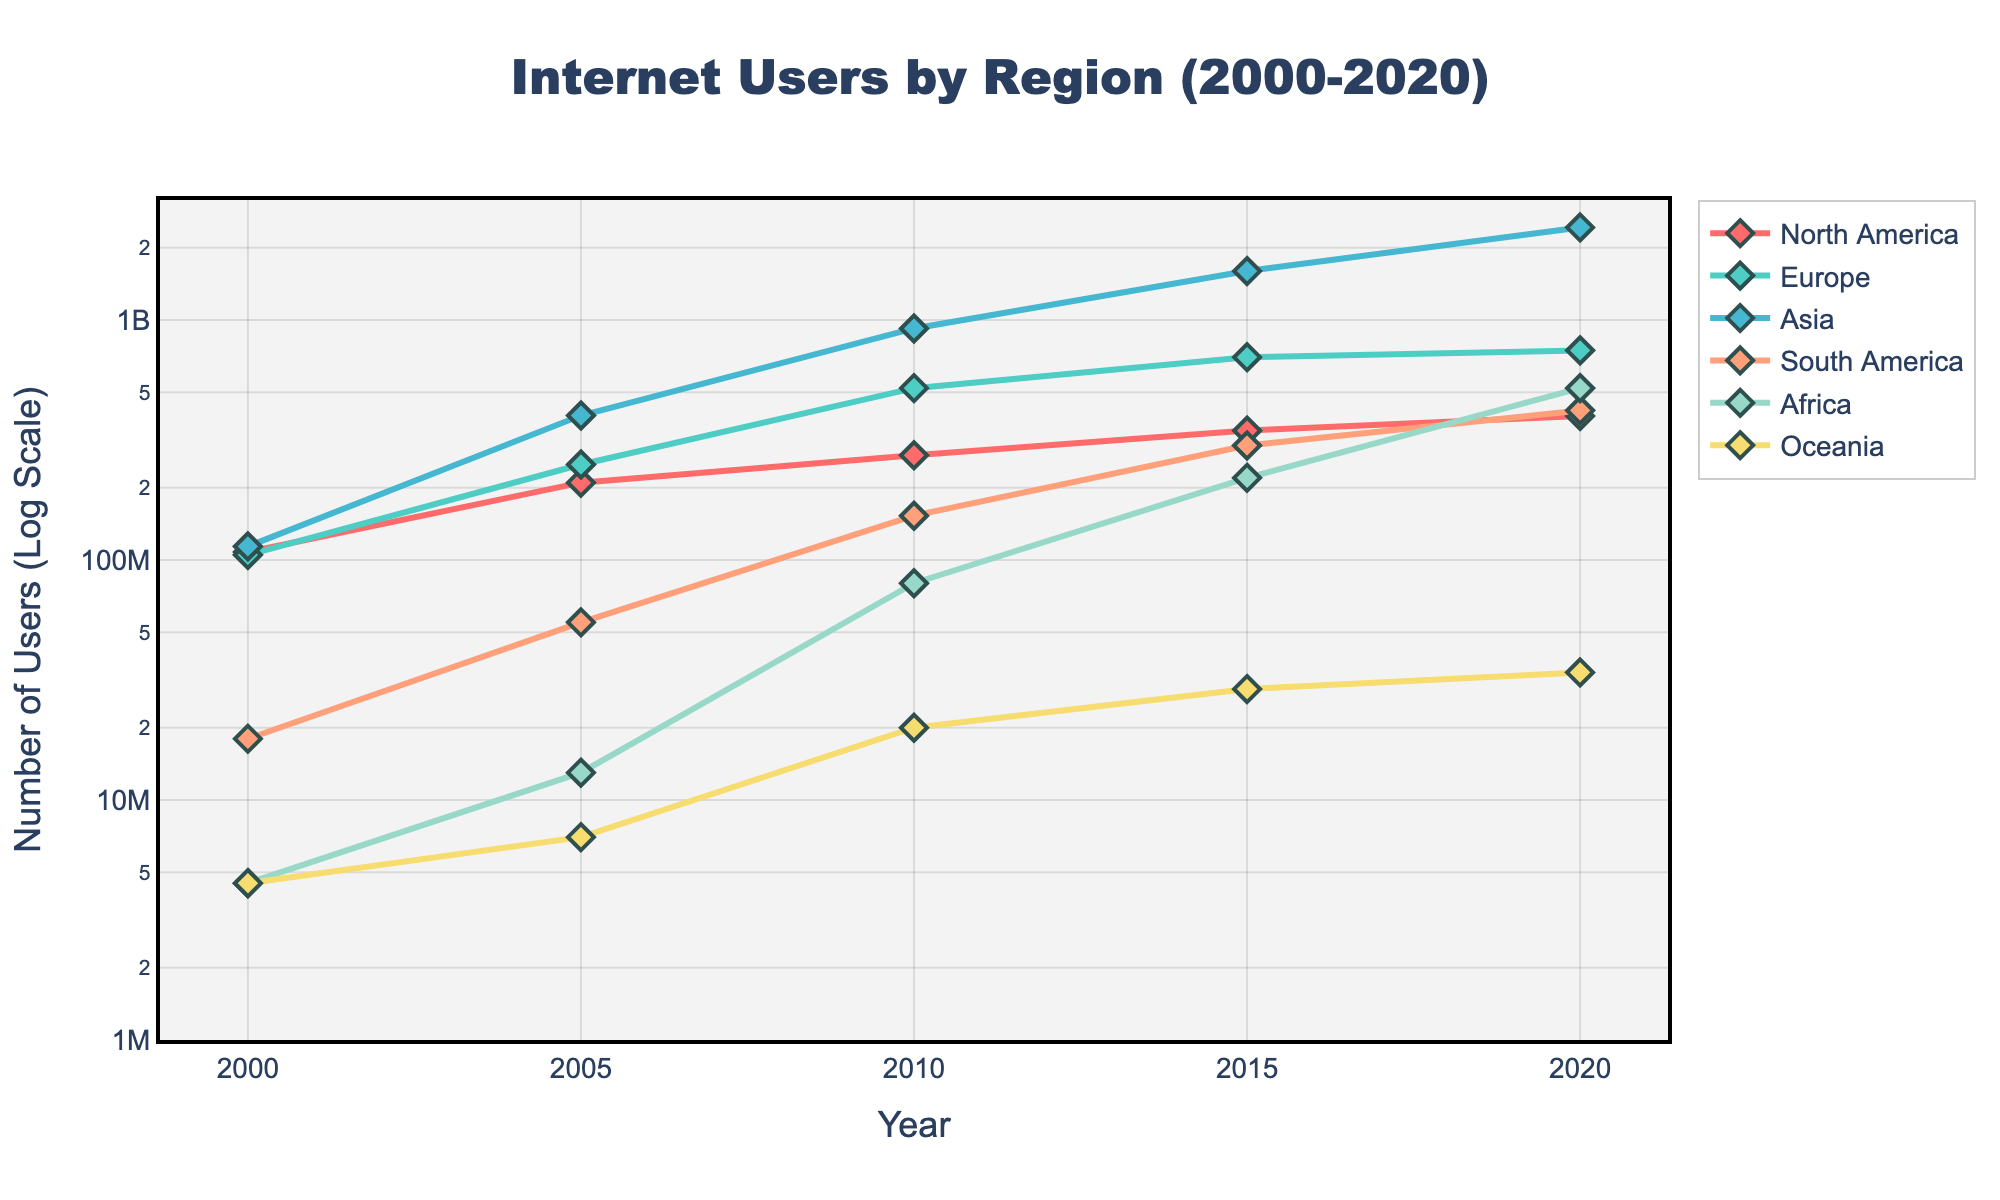What is the title of the plot? The title is usually at the top of the plot and provides a brief description of what the plot represents. Here, it's right in the center top of the plot, above the lines and markers.
Answer: Internet Users by Region (2000-2020) What does the y-axis represent? The y-axis typically represents a quantitative measure. In this plot, it is labeled clearly and indicates that it measures the number of internet users on a logarithmic scale.
Answer: Number of Users (Log Scale) Which region had the smallest number of internet users in 2000? We look at the data points for 2000 along the x-axis and compare their values on the y-axis. The lowest data point among the regions for that year indicates the smallest number of users.
Answer: Oceania Between 2010 and 2015, which region saw the largest increase in internet users? We compare the vertical distances between the points for each region from 2010 to 2015 on the y-axis. The region with the largest vertical difference represents the biggest increase.
Answer: Asia How many internet users were there in Europe in 2020? We locate the data point for Europe at the year 2020 on the x-axis and read the corresponding value on the y-axis.
Answer: 747,000,000 In which year did North America first reach more than 300 million internet users? We track the data points for North America along the x-axis and find the year where the value first exceeds 300 million on the y-axis.
Answer: 2010 Which region had the fastest growth rate from 2000 to 2015? By looking at the slopes of the lines for each region from 2000 to 2015, the steepest line indicates the fastest growth rate.
Answer: Asia What is the approximate ratio of internet users in Africa to those in North America in 2020? We find the values for Africa and North America in 2020 on the y-axis and then divide the number of users in Africa by the number of users in North America.
Answer: ~1.31 Which region had more internet users: South America in 2015 or Europe in 2005? We compare the data points for South America in 2015 and Europe in 2005 by finding their respective values on the y-axis.
Answer: South America in 2015 From 2000 to 2020, which year showed the most significant growth in internet users for Asia? By examining the distances between sequential data points for Asia, the largest vertical gap on the y-axis represents the year with the most significant growth.
Answer: 2015 